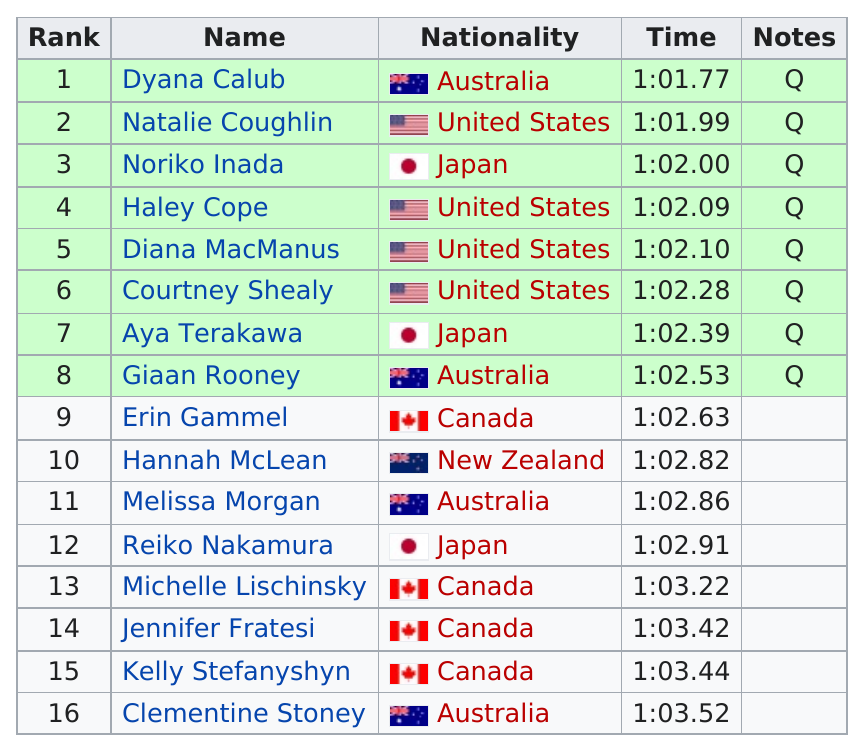Point out several critical features in this image. It is not clear what you are asking. Could you please provide more context or clarify your question? It is not clear which individual, Aya Terakawa or Erin Gammel, ranked higher. In the 2002 Pan Pacific Swimming Championships, during the women's 100 metre backstroke event, a total of nine competitors required at least 1:02.50 to finish. In the 2002 Pan Pacific Swimming Championships, the United States placed the most women's swimmers in the top eight in the 100 metre backstroke event. Erin Gammel was the first Canadian player to finish. 